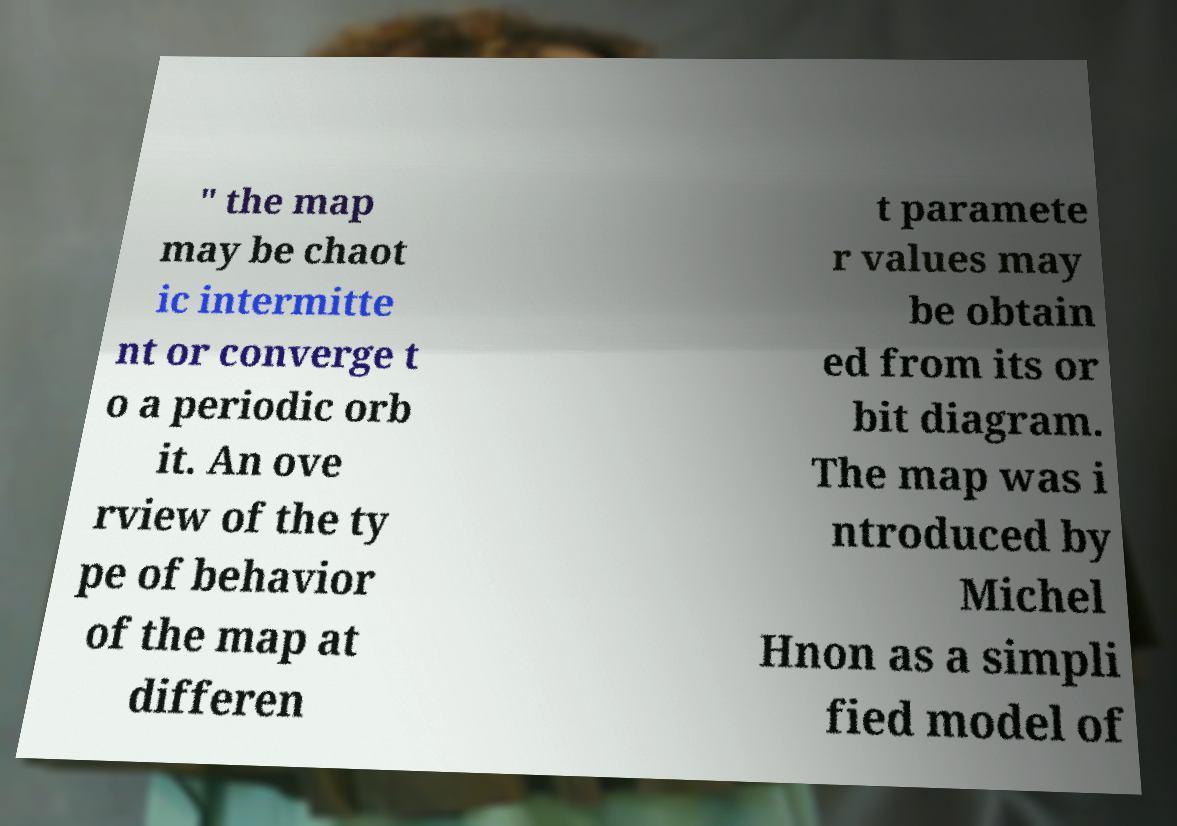Can you read and provide the text displayed in the image?This photo seems to have some interesting text. Can you extract and type it out for me? " the map may be chaot ic intermitte nt or converge t o a periodic orb it. An ove rview of the ty pe of behavior of the map at differen t paramete r values may be obtain ed from its or bit diagram. The map was i ntroduced by Michel Hnon as a simpli fied model of 